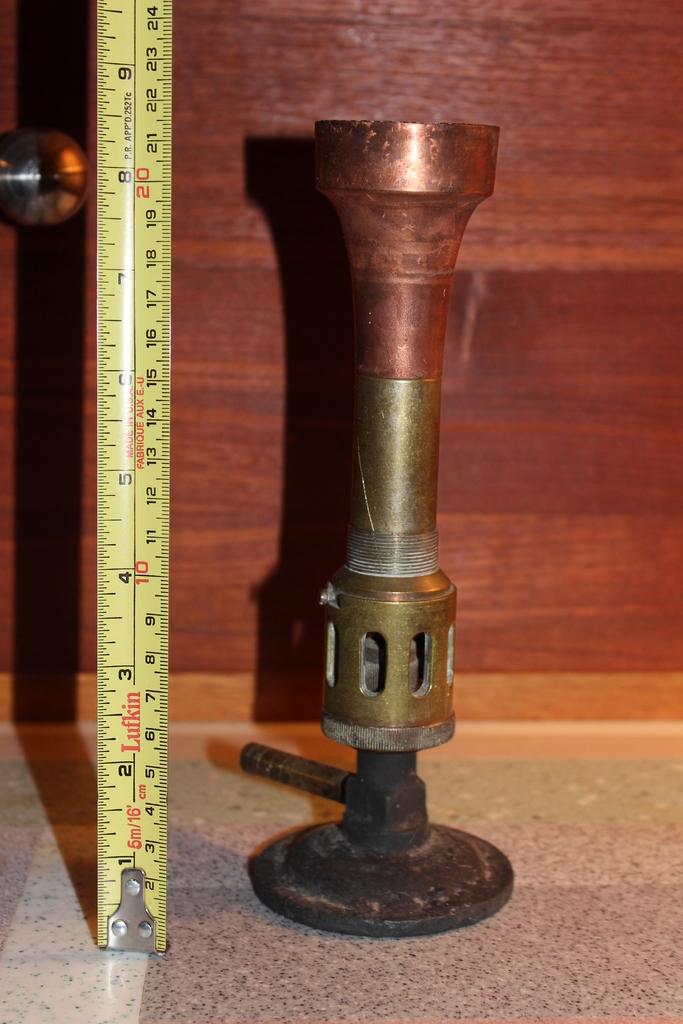How tall is the object?
Ensure brevity in your answer.  8.5 inches. Who made this ruler?
Offer a very short reply. Lufkin. 